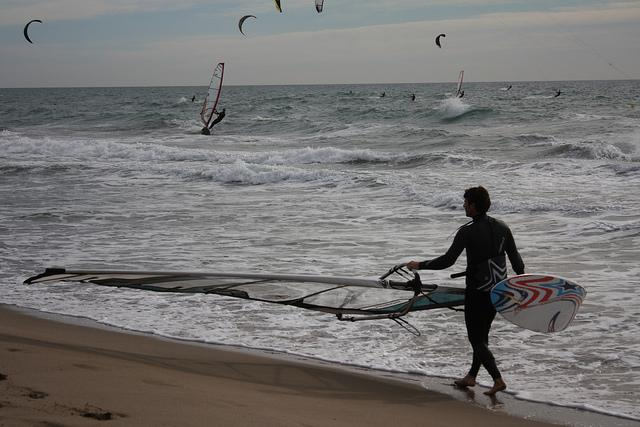What is the parachute called in paragliding? paramotor 